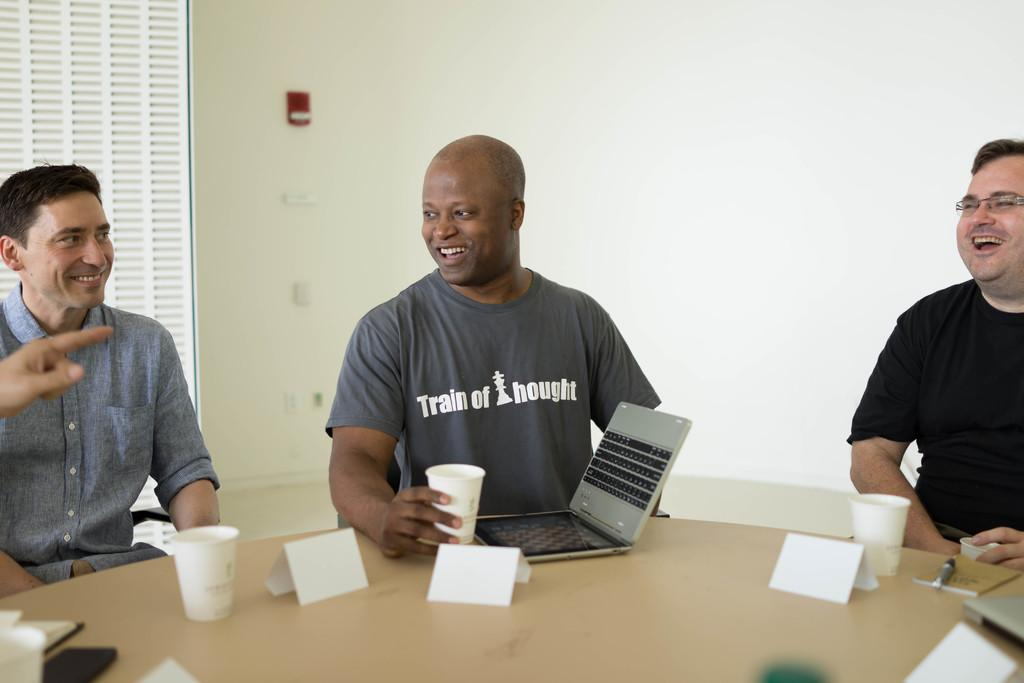How many people are present in the image? There are three people in the image. What object is in front of the people? There is a laptop in front of the people. What can be seen on the table in the image? There is a cup on the table. What is visible at the back of the scene? There is a wall at the back of the scene. How many oranges are on the table in the image? There are no oranges present in the image. Can you see any cats in the image? There are no cats visible in the image. 